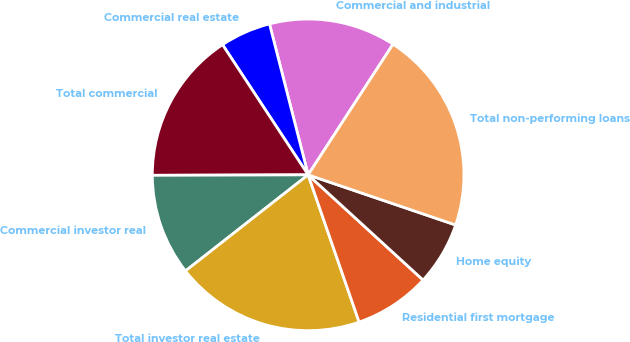Convert chart. <chart><loc_0><loc_0><loc_500><loc_500><pie_chart><fcel>Commercial and industrial<fcel>Commercial real estate<fcel>Total commercial<fcel>Commercial investor real<fcel>Total investor real estate<fcel>Residential first mortgage<fcel>Home equity<fcel>Total non-performing loans<nl><fcel>13.16%<fcel>5.27%<fcel>15.79%<fcel>10.53%<fcel>19.73%<fcel>7.9%<fcel>6.58%<fcel>21.05%<nl></chart> 